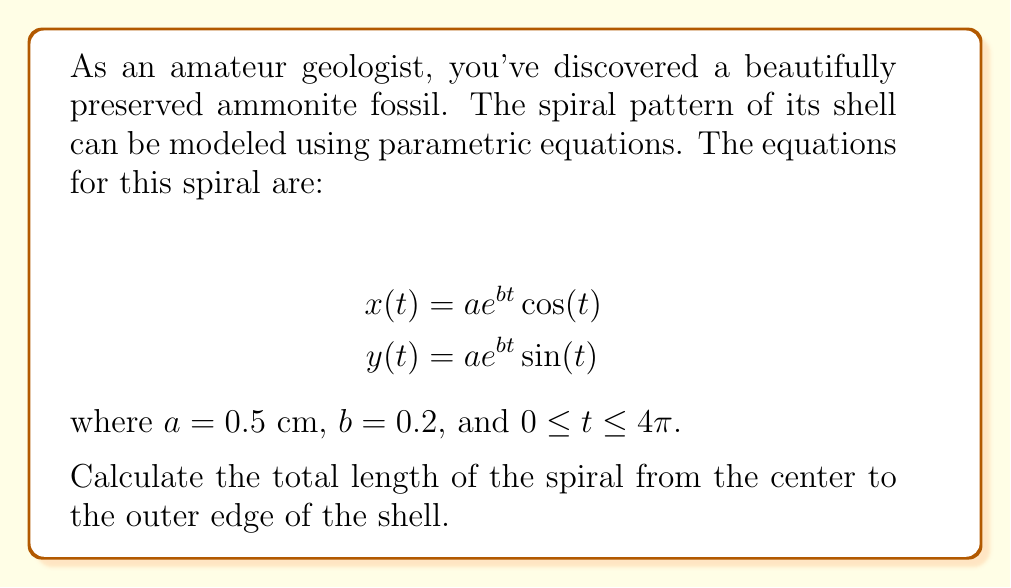Teach me how to tackle this problem. To find the length of the spiral, we need to use the arc length formula for parametric equations:

$$L = \int_{t_1}^{t_2} \sqrt{\left(\frac{dx}{dt}\right)^2 + \left(\frac{dy}{dt}\right)^2} dt$$

Step 1: Find $\frac{dx}{dt}$ and $\frac{dy}{dt}$
$$\frac{dx}{dt} = ae^{bt}(b\cos(t) - \sin(t))$$
$$\frac{dy}{dt} = ae^{bt}(b\sin(t) + \cos(t))$$

Step 2: Substitute these into the arc length formula
$$L = \int_{0}^{4\pi} \sqrt{(ae^{bt}(b\cos(t) - \sin(t)))^2 + (ae^{bt}(b\sin(t) + \cos(t)))^2} dt$$

Step 3: Simplify the expression under the square root
$$(ae^{bt}(b\cos(t) - \sin(t)))^2 + (ae^{bt}(b\sin(t) + \cos(t)))^2$$
$$= a^2e^{2bt}((b\cos(t) - \sin(t))^2 + (b\sin(t) + \cos(t))^2)$$
$$= a^2e^{2bt}(b^2\cos^2(t) - 2b\cos(t)\sin(t) + \sin^2(t) + b^2\sin^2(t) + 2b\sin(t)\cos(t) + \cos^2(t))$$
$$= a^2e^{2bt}(b^2(\cos^2(t) + \sin^2(t)) + (\sin^2(t) + \cos^2(t)))$$
$$= a^2e^{2bt}(b^2 + 1)$$

Step 4: Substitute this back into the integral
$$L = \int_{0}^{4\pi} ae^{bt}\sqrt{b^2 + 1} dt$$

Step 5: Evaluate the integral
$$L = a\sqrt{b^2 + 1} \int_{0}^{4\pi} e^{bt} dt$$
$$= a\sqrt{b^2 + 1} \left[\frac{1}{b}e^{bt}\right]_{0}^{4\pi}$$
$$= \frac{a\sqrt{b^2 + 1}}{b} (e^{4\pi b} - 1)$$

Step 6: Substitute the given values ($a = 0.5$ cm, $b = 0.2$)
$$L = \frac{0.5\sqrt{0.2^2 + 1}}{0.2} (e^{4\pi (0.2)} - 1)$$
$$\approx 11.85 \text{ cm}$$
Answer: The total length of the spiral from the center to the outer edge of the ammonite shell is approximately 11.85 cm. 